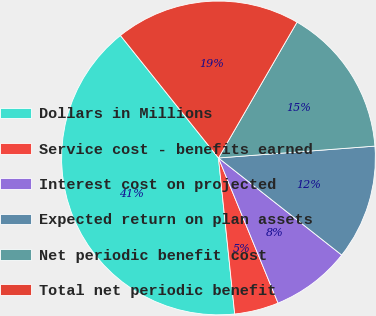Convert chart to OTSL. <chart><loc_0><loc_0><loc_500><loc_500><pie_chart><fcel>Dollars in Millions<fcel>Service cost - benefits earned<fcel>Interest cost on projected<fcel>Expected return on plan assets<fcel>Net periodic benefit cost<fcel>Total net periodic benefit<nl><fcel>40.9%<fcel>4.55%<fcel>8.18%<fcel>11.82%<fcel>15.45%<fcel>19.09%<nl></chart> 